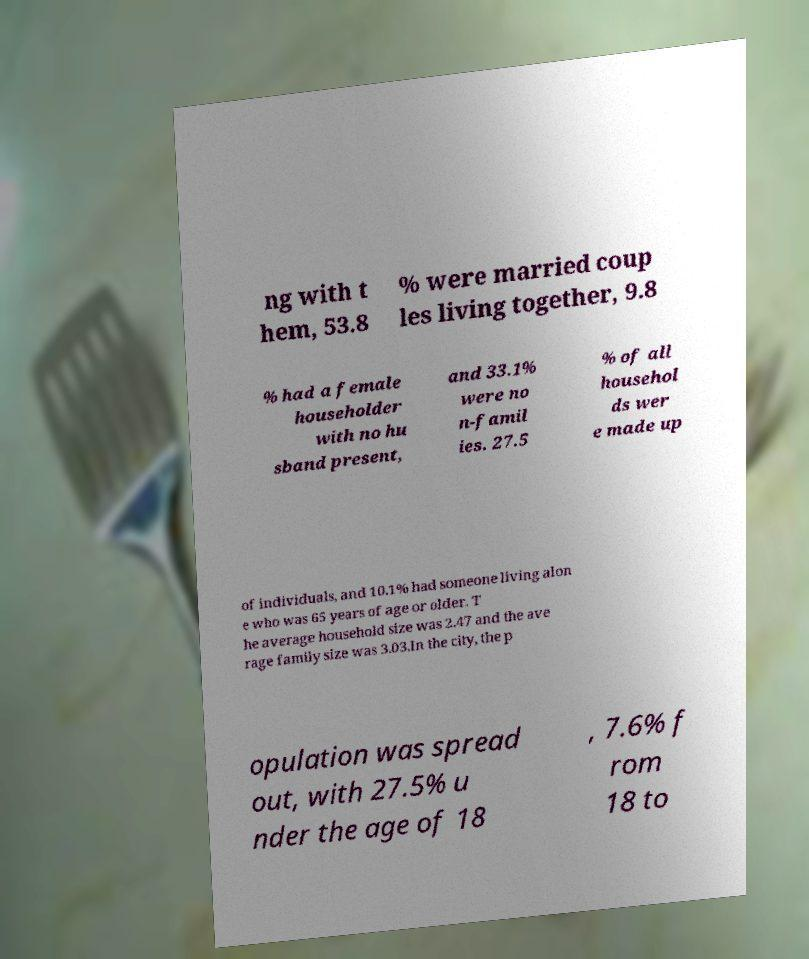Please identify and transcribe the text found in this image. ng with t hem, 53.8 % were married coup les living together, 9.8 % had a female householder with no hu sband present, and 33.1% were no n-famil ies. 27.5 % of all househol ds wer e made up of individuals, and 10.1% had someone living alon e who was 65 years of age or older. T he average household size was 2.47 and the ave rage family size was 3.03.In the city, the p opulation was spread out, with 27.5% u nder the age of 18 , 7.6% f rom 18 to 